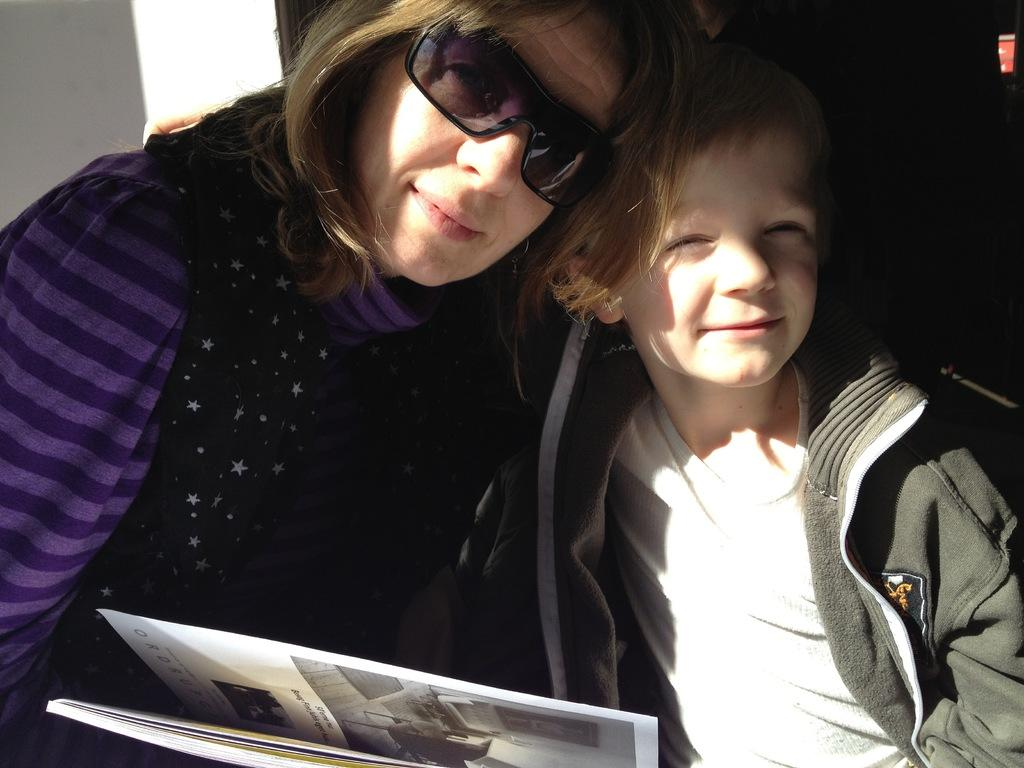What is the person wearing in the image? The person is wearing spectacles in the image. What is the kid wearing in the image? The kid is wearing a jacket in the image. What object is present between the person and the kid in the image? There is a book in front of them in the image. Can you tell me how many wrens are sitting on the book in the image? There are no wrens present in the image; it only features a person, a kid, and a book. What type of conversation is the person and the kid having in the image? The image does not show any conversation or interaction between the person and the kid, so it cannot be determined what they might be talking about. 